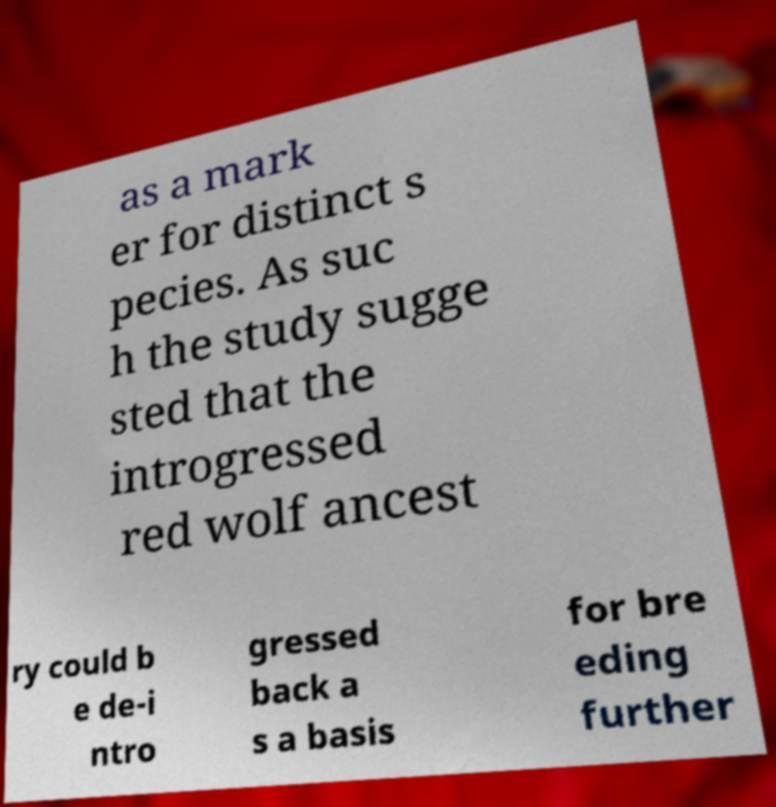There's text embedded in this image that I need extracted. Can you transcribe it verbatim? as a mark er for distinct s pecies. As suc h the study sugge sted that the introgressed red wolf ancest ry could b e de-i ntro gressed back a s a basis for bre eding further 